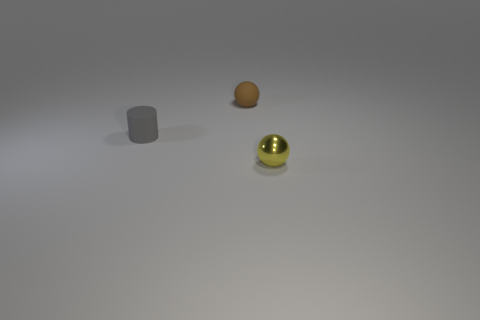Add 2 small gray matte things. How many objects exist? 5 Subtract all spheres. How many objects are left? 1 Add 1 purple spheres. How many purple spheres exist? 1 Subtract 0 cyan cylinders. How many objects are left? 3 Subtract all tiny metal spheres. Subtract all gray things. How many objects are left? 1 Add 3 small yellow metallic balls. How many small yellow metallic balls are left? 4 